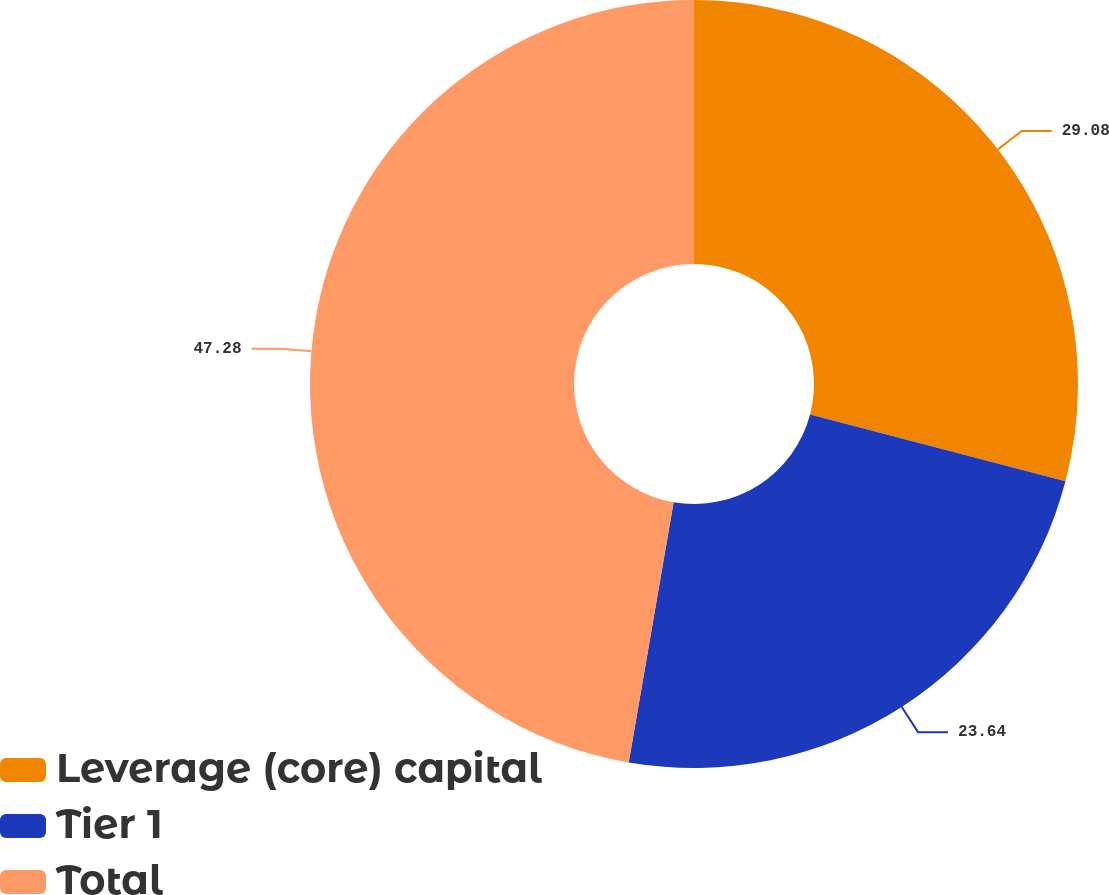Convert chart. <chart><loc_0><loc_0><loc_500><loc_500><pie_chart><fcel>Leverage (core) capital<fcel>Tier 1<fcel>Total<nl><fcel>29.08%<fcel>23.64%<fcel>47.28%<nl></chart> 